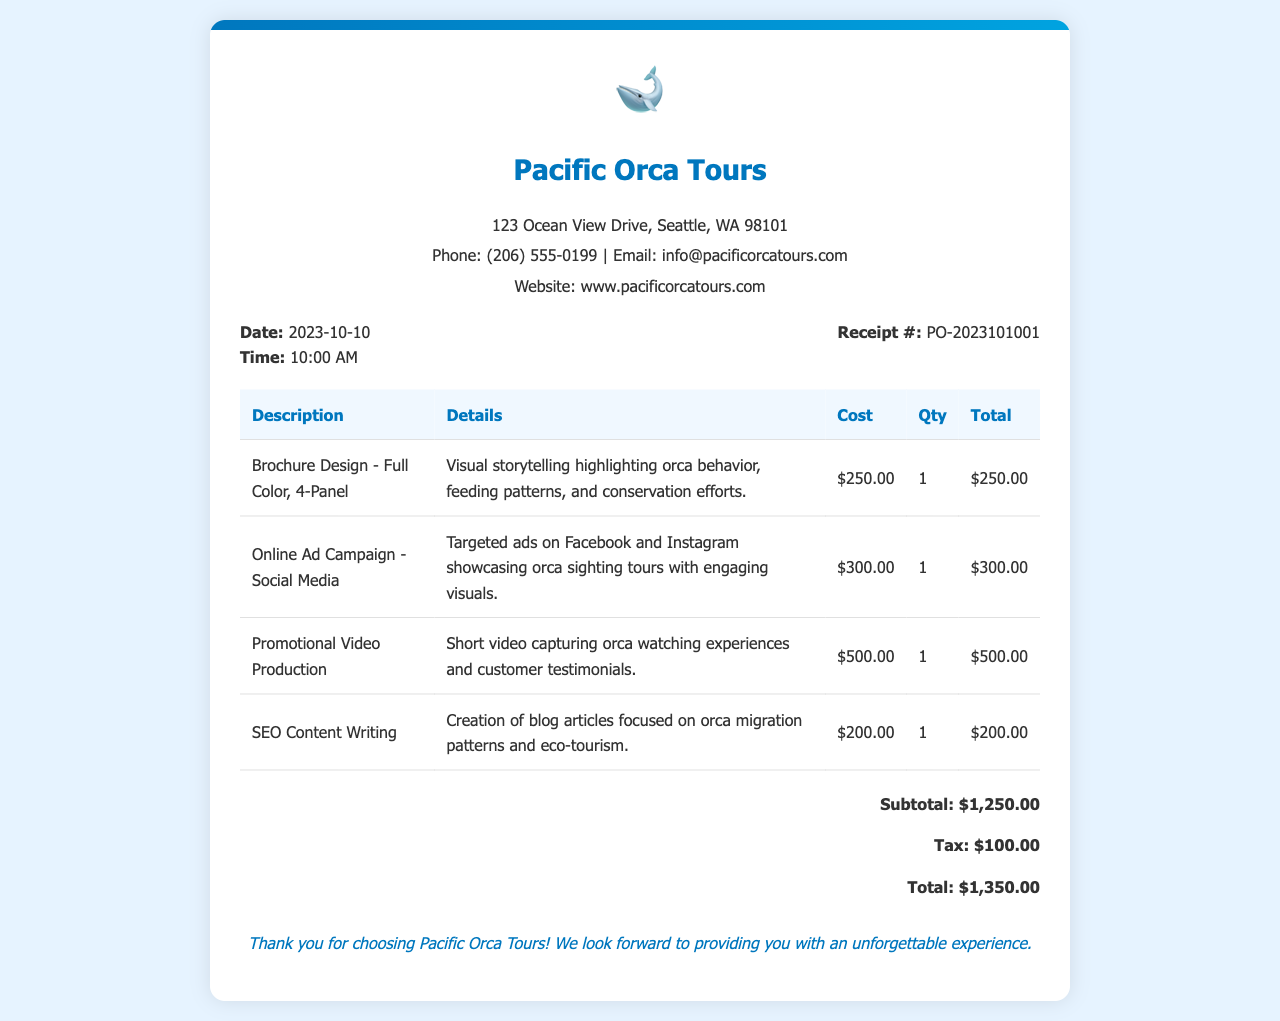What is the receipt date? The receipt date is found under the receipt details section, listed as "Date: 2023-10-10."
Answer: 2023-10-10 What is the total amount billed? The total amount billed can be found in the total section, which states "Total: $1,350.00."
Answer: $1,350.00 How many items are listed in the receipt? By counting the number of rows in the itemized table, there are four items listed.
Answer: 4 What is the cost of the Promotional Video Production? The cost of the Promotional Video Production is specified in the itemized table under "Cost."
Answer: $500.00 What type of document is this? This document is a receipt, indicated by its title and overall formatting, which includes details of a purchase.
Answer: Receipt How much was spent on SEO Content Writing? The amount spent on SEO Content Writing can be found in its respective row as listed in the table.
Answer: $200.00 What is the tax amount? The tax amount is indicated in the total section as "Tax: $100.00."
Answer: $100.00 What description is provided for the Brochure Design? The description for the Brochure Design can be found in the Details column of the table.
Answer: Visual storytelling highlighting orca behavior, feeding patterns, and conservation efforts 